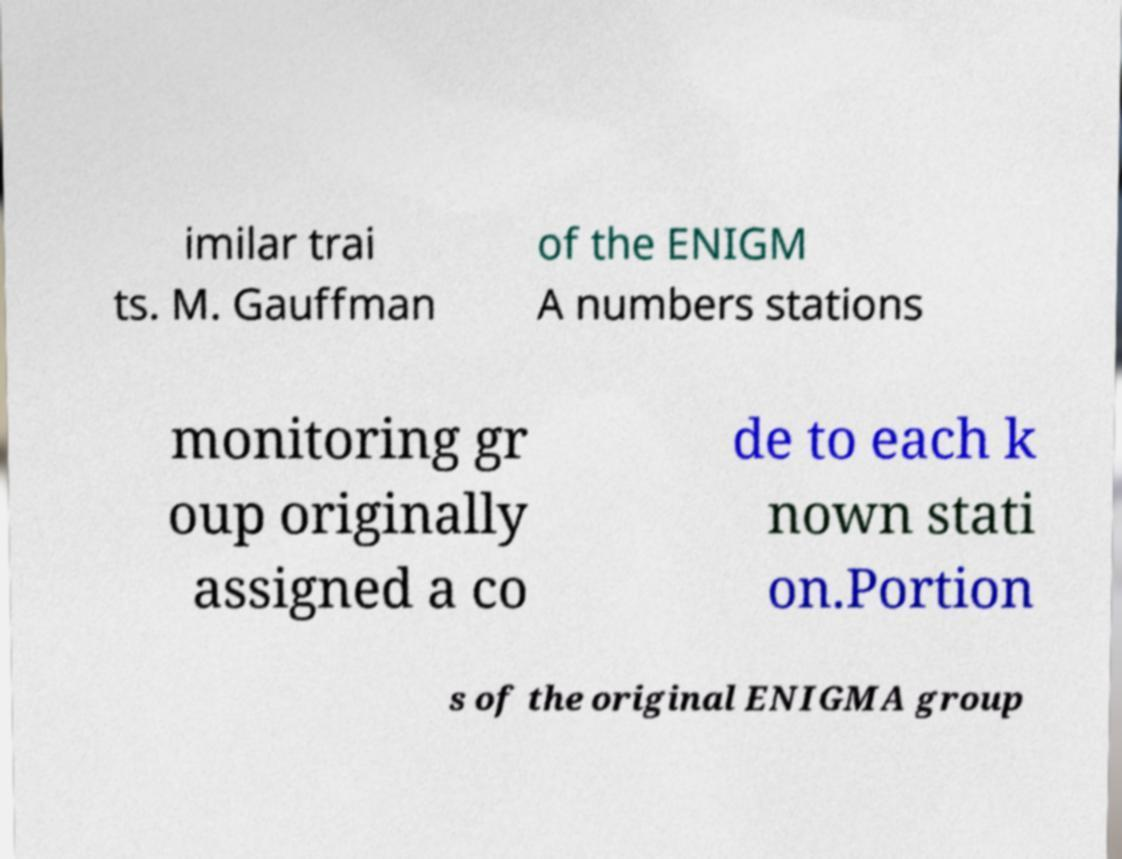Could you extract and type out the text from this image? imilar trai ts. M. Gauffman of the ENIGM A numbers stations monitoring gr oup originally assigned a co de to each k nown stati on.Portion s of the original ENIGMA group 